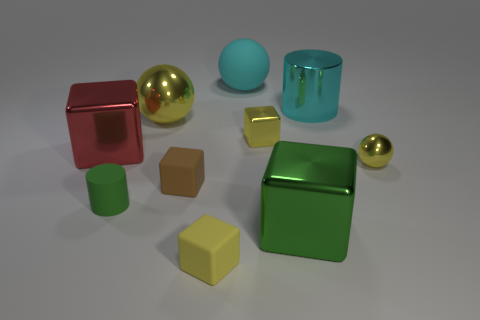What number of gray objects are large matte spheres or matte blocks?
Your response must be concise. 0. Is there anything else of the same color as the rubber sphere?
Offer a terse response. Yes. There is a ball that is behind the yellow metallic sphere to the left of the cyan metallic object; what color is it?
Ensure brevity in your answer.  Cyan. Is the number of tiny matte cylinders to the right of the tiny cylinder less than the number of big yellow metallic spheres in front of the red block?
Provide a succinct answer. No. There is a object that is the same color as the large cylinder; what material is it?
Offer a very short reply. Rubber. How many objects are either large objects left of the tiny metal block or brown shiny objects?
Give a very brief answer. 3. There is a metallic ball in front of the red thing; is its size the same as the big red block?
Offer a very short reply. No. Is the number of big yellow spheres right of the yellow matte thing less than the number of small purple shiny balls?
Keep it short and to the point. No. There is a yellow ball that is the same size as the yellow matte block; what is its material?
Your answer should be compact. Metal. How many big things are gray metal cylinders or green blocks?
Make the answer very short. 1. 